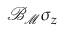Convert formula to latex. <formula><loc_0><loc_0><loc_500><loc_500>{ \mathcal { B } } _ { { \mathcal { M } } } \sigma _ { z }</formula> 